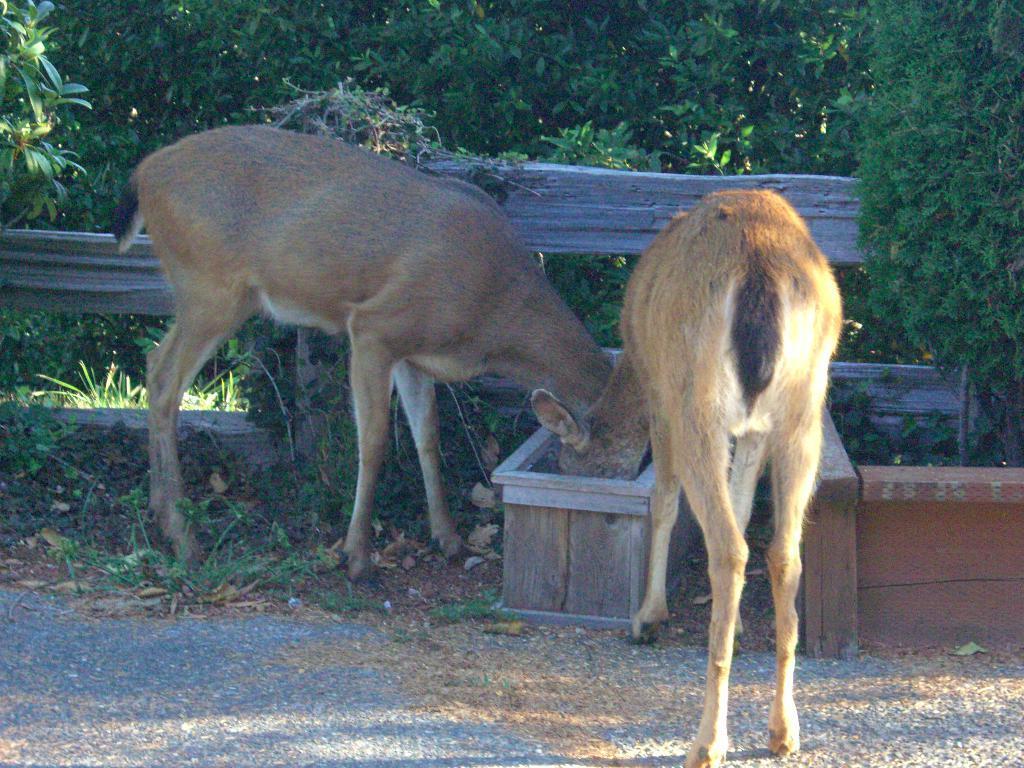Could you give a brief overview of what you see in this image? In the image there are two animals eating something which is in the box. Behind them there is a wooden fencing. In the background there are trees. 